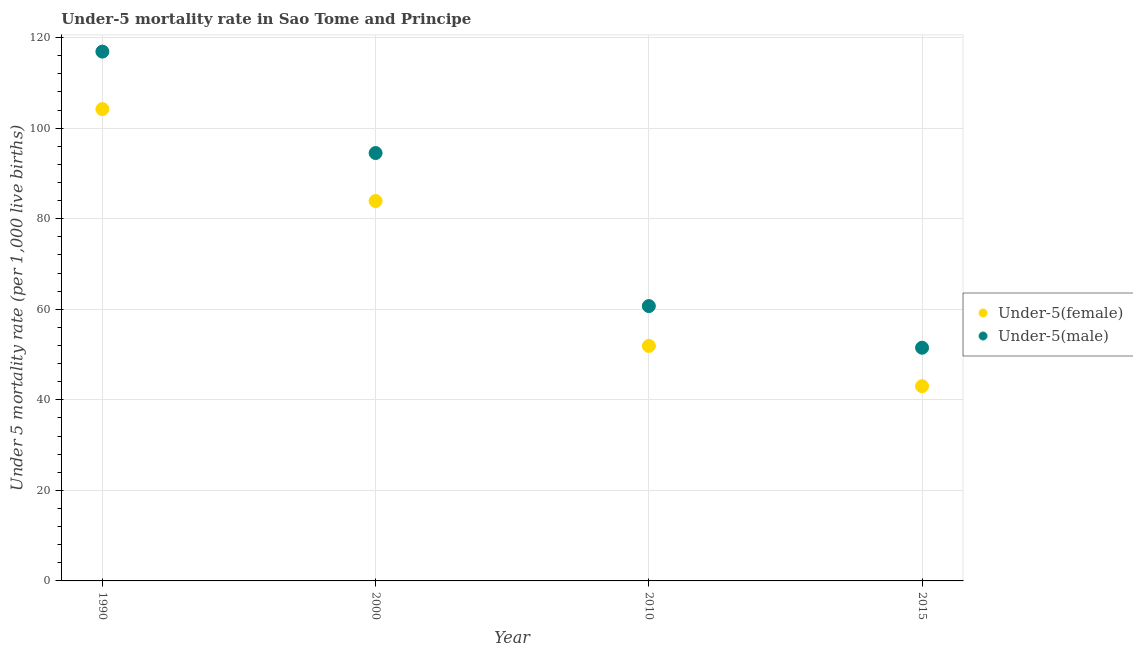Across all years, what is the maximum under-5 male mortality rate?
Offer a very short reply. 116.9. Across all years, what is the minimum under-5 female mortality rate?
Offer a very short reply. 43. In which year was the under-5 male mortality rate maximum?
Make the answer very short. 1990. In which year was the under-5 female mortality rate minimum?
Your answer should be very brief. 2015. What is the total under-5 female mortality rate in the graph?
Provide a short and direct response. 283. What is the difference between the under-5 female mortality rate in 2000 and that in 2015?
Your response must be concise. 40.9. What is the difference between the under-5 female mortality rate in 2010 and the under-5 male mortality rate in 2000?
Make the answer very short. -42.6. What is the average under-5 male mortality rate per year?
Offer a very short reply. 80.9. In the year 2010, what is the difference between the under-5 male mortality rate and under-5 female mortality rate?
Make the answer very short. 8.8. In how many years, is the under-5 male mortality rate greater than 104?
Make the answer very short. 1. What is the ratio of the under-5 male mortality rate in 2000 to that in 2010?
Provide a succinct answer. 1.56. Is the difference between the under-5 male mortality rate in 2010 and 2015 greater than the difference between the under-5 female mortality rate in 2010 and 2015?
Your response must be concise. Yes. What is the difference between the highest and the second highest under-5 male mortality rate?
Make the answer very short. 22.4. What is the difference between the highest and the lowest under-5 male mortality rate?
Give a very brief answer. 65.4. In how many years, is the under-5 male mortality rate greater than the average under-5 male mortality rate taken over all years?
Your answer should be compact. 2. Is the under-5 male mortality rate strictly greater than the under-5 female mortality rate over the years?
Ensure brevity in your answer.  Yes. Is the under-5 male mortality rate strictly less than the under-5 female mortality rate over the years?
Your answer should be very brief. No. What is the difference between two consecutive major ticks on the Y-axis?
Keep it short and to the point. 20. Are the values on the major ticks of Y-axis written in scientific E-notation?
Keep it short and to the point. No. Does the graph contain any zero values?
Offer a very short reply. No. Does the graph contain grids?
Make the answer very short. Yes. Where does the legend appear in the graph?
Offer a very short reply. Center right. How many legend labels are there?
Your answer should be very brief. 2. What is the title of the graph?
Offer a very short reply. Under-5 mortality rate in Sao Tome and Principe. What is the label or title of the Y-axis?
Make the answer very short. Under 5 mortality rate (per 1,0 live births). What is the Under 5 mortality rate (per 1,000 live births) of Under-5(female) in 1990?
Your answer should be compact. 104.2. What is the Under 5 mortality rate (per 1,000 live births) of Under-5(male) in 1990?
Offer a terse response. 116.9. What is the Under 5 mortality rate (per 1,000 live births) of Under-5(female) in 2000?
Your response must be concise. 83.9. What is the Under 5 mortality rate (per 1,000 live births) of Under-5(male) in 2000?
Give a very brief answer. 94.5. What is the Under 5 mortality rate (per 1,000 live births) of Under-5(female) in 2010?
Offer a terse response. 51.9. What is the Under 5 mortality rate (per 1,000 live births) in Under-5(male) in 2010?
Your response must be concise. 60.7. What is the Under 5 mortality rate (per 1,000 live births) in Under-5(male) in 2015?
Your answer should be compact. 51.5. Across all years, what is the maximum Under 5 mortality rate (per 1,000 live births) of Under-5(female)?
Make the answer very short. 104.2. Across all years, what is the maximum Under 5 mortality rate (per 1,000 live births) of Under-5(male)?
Ensure brevity in your answer.  116.9. Across all years, what is the minimum Under 5 mortality rate (per 1,000 live births) of Under-5(female)?
Your response must be concise. 43. Across all years, what is the minimum Under 5 mortality rate (per 1,000 live births) of Under-5(male)?
Your answer should be compact. 51.5. What is the total Under 5 mortality rate (per 1,000 live births) of Under-5(female) in the graph?
Your response must be concise. 283. What is the total Under 5 mortality rate (per 1,000 live births) of Under-5(male) in the graph?
Provide a short and direct response. 323.6. What is the difference between the Under 5 mortality rate (per 1,000 live births) of Under-5(female) in 1990 and that in 2000?
Offer a terse response. 20.3. What is the difference between the Under 5 mortality rate (per 1,000 live births) of Under-5(male) in 1990 and that in 2000?
Your response must be concise. 22.4. What is the difference between the Under 5 mortality rate (per 1,000 live births) in Under-5(female) in 1990 and that in 2010?
Provide a short and direct response. 52.3. What is the difference between the Under 5 mortality rate (per 1,000 live births) in Under-5(male) in 1990 and that in 2010?
Give a very brief answer. 56.2. What is the difference between the Under 5 mortality rate (per 1,000 live births) of Under-5(female) in 1990 and that in 2015?
Ensure brevity in your answer.  61.2. What is the difference between the Under 5 mortality rate (per 1,000 live births) in Under-5(male) in 1990 and that in 2015?
Give a very brief answer. 65.4. What is the difference between the Under 5 mortality rate (per 1,000 live births) in Under-5(female) in 2000 and that in 2010?
Give a very brief answer. 32. What is the difference between the Under 5 mortality rate (per 1,000 live births) in Under-5(male) in 2000 and that in 2010?
Your answer should be compact. 33.8. What is the difference between the Under 5 mortality rate (per 1,000 live births) of Under-5(female) in 2000 and that in 2015?
Keep it short and to the point. 40.9. What is the difference between the Under 5 mortality rate (per 1,000 live births) of Under-5(male) in 2000 and that in 2015?
Give a very brief answer. 43. What is the difference between the Under 5 mortality rate (per 1,000 live births) in Under-5(female) in 1990 and the Under 5 mortality rate (per 1,000 live births) in Under-5(male) in 2010?
Make the answer very short. 43.5. What is the difference between the Under 5 mortality rate (per 1,000 live births) of Under-5(female) in 1990 and the Under 5 mortality rate (per 1,000 live births) of Under-5(male) in 2015?
Give a very brief answer. 52.7. What is the difference between the Under 5 mortality rate (per 1,000 live births) of Under-5(female) in 2000 and the Under 5 mortality rate (per 1,000 live births) of Under-5(male) in 2010?
Ensure brevity in your answer.  23.2. What is the difference between the Under 5 mortality rate (per 1,000 live births) of Under-5(female) in 2000 and the Under 5 mortality rate (per 1,000 live births) of Under-5(male) in 2015?
Provide a succinct answer. 32.4. What is the difference between the Under 5 mortality rate (per 1,000 live births) of Under-5(female) in 2010 and the Under 5 mortality rate (per 1,000 live births) of Under-5(male) in 2015?
Keep it short and to the point. 0.4. What is the average Under 5 mortality rate (per 1,000 live births) in Under-5(female) per year?
Provide a succinct answer. 70.75. What is the average Under 5 mortality rate (per 1,000 live births) in Under-5(male) per year?
Your answer should be compact. 80.9. In the year 1990, what is the difference between the Under 5 mortality rate (per 1,000 live births) of Under-5(female) and Under 5 mortality rate (per 1,000 live births) of Under-5(male)?
Offer a very short reply. -12.7. In the year 2000, what is the difference between the Under 5 mortality rate (per 1,000 live births) of Under-5(female) and Under 5 mortality rate (per 1,000 live births) of Under-5(male)?
Offer a very short reply. -10.6. What is the ratio of the Under 5 mortality rate (per 1,000 live births) in Under-5(female) in 1990 to that in 2000?
Your answer should be compact. 1.24. What is the ratio of the Under 5 mortality rate (per 1,000 live births) in Under-5(male) in 1990 to that in 2000?
Your answer should be very brief. 1.24. What is the ratio of the Under 5 mortality rate (per 1,000 live births) of Under-5(female) in 1990 to that in 2010?
Offer a terse response. 2.01. What is the ratio of the Under 5 mortality rate (per 1,000 live births) in Under-5(male) in 1990 to that in 2010?
Make the answer very short. 1.93. What is the ratio of the Under 5 mortality rate (per 1,000 live births) of Under-5(female) in 1990 to that in 2015?
Ensure brevity in your answer.  2.42. What is the ratio of the Under 5 mortality rate (per 1,000 live births) in Under-5(male) in 1990 to that in 2015?
Offer a very short reply. 2.27. What is the ratio of the Under 5 mortality rate (per 1,000 live births) in Under-5(female) in 2000 to that in 2010?
Offer a terse response. 1.62. What is the ratio of the Under 5 mortality rate (per 1,000 live births) of Under-5(male) in 2000 to that in 2010?
Your answer should be compact. 1.56. What is the ratio of the Under 5 mortality rate (per 1,000 live births) of Under-5(female) in 2000 to that in 2015?
Make the answer very short. 1.95. What is the ratio of the Under 5 mortality rate (per 1,000 live births) of Under-5(male) in 2000 to that in 2015?
Ensure brevity in your answer.  1.83. What is the ratio of the Under 5 mortality rate (per 1,000 live births) of Under-5(female) in 2010 to that in 2015?
Make the answer very short. 1.21. What is the ratio of the Under 5 mortality rate (per 1,000 live births) of Under-5(male) in 2010 to that in 2015?
Give a very brief answer. 1.18. What is the difference between the highest and the second highest Under 5 mortality rate (per 1,000 live births) of Under-5(female)?
Offer a terse response. 20.3. What is the difference between the highest and the second highest Under 5 mortality rate (per 1,000 live births) in Under-5(male)?
Offer a very short reply. 22.4. What is the difference between the highest and the lowest Under 5 mortality rate (per 1,000 live births) in Under-5(female)?
Your answer should be very brief. 61.2. What is the difference between the highest and the lowest Under 5 mortality rate (per 1,000 live births) of Under-5(male)?
Provide a short and direct response. 65.4. 